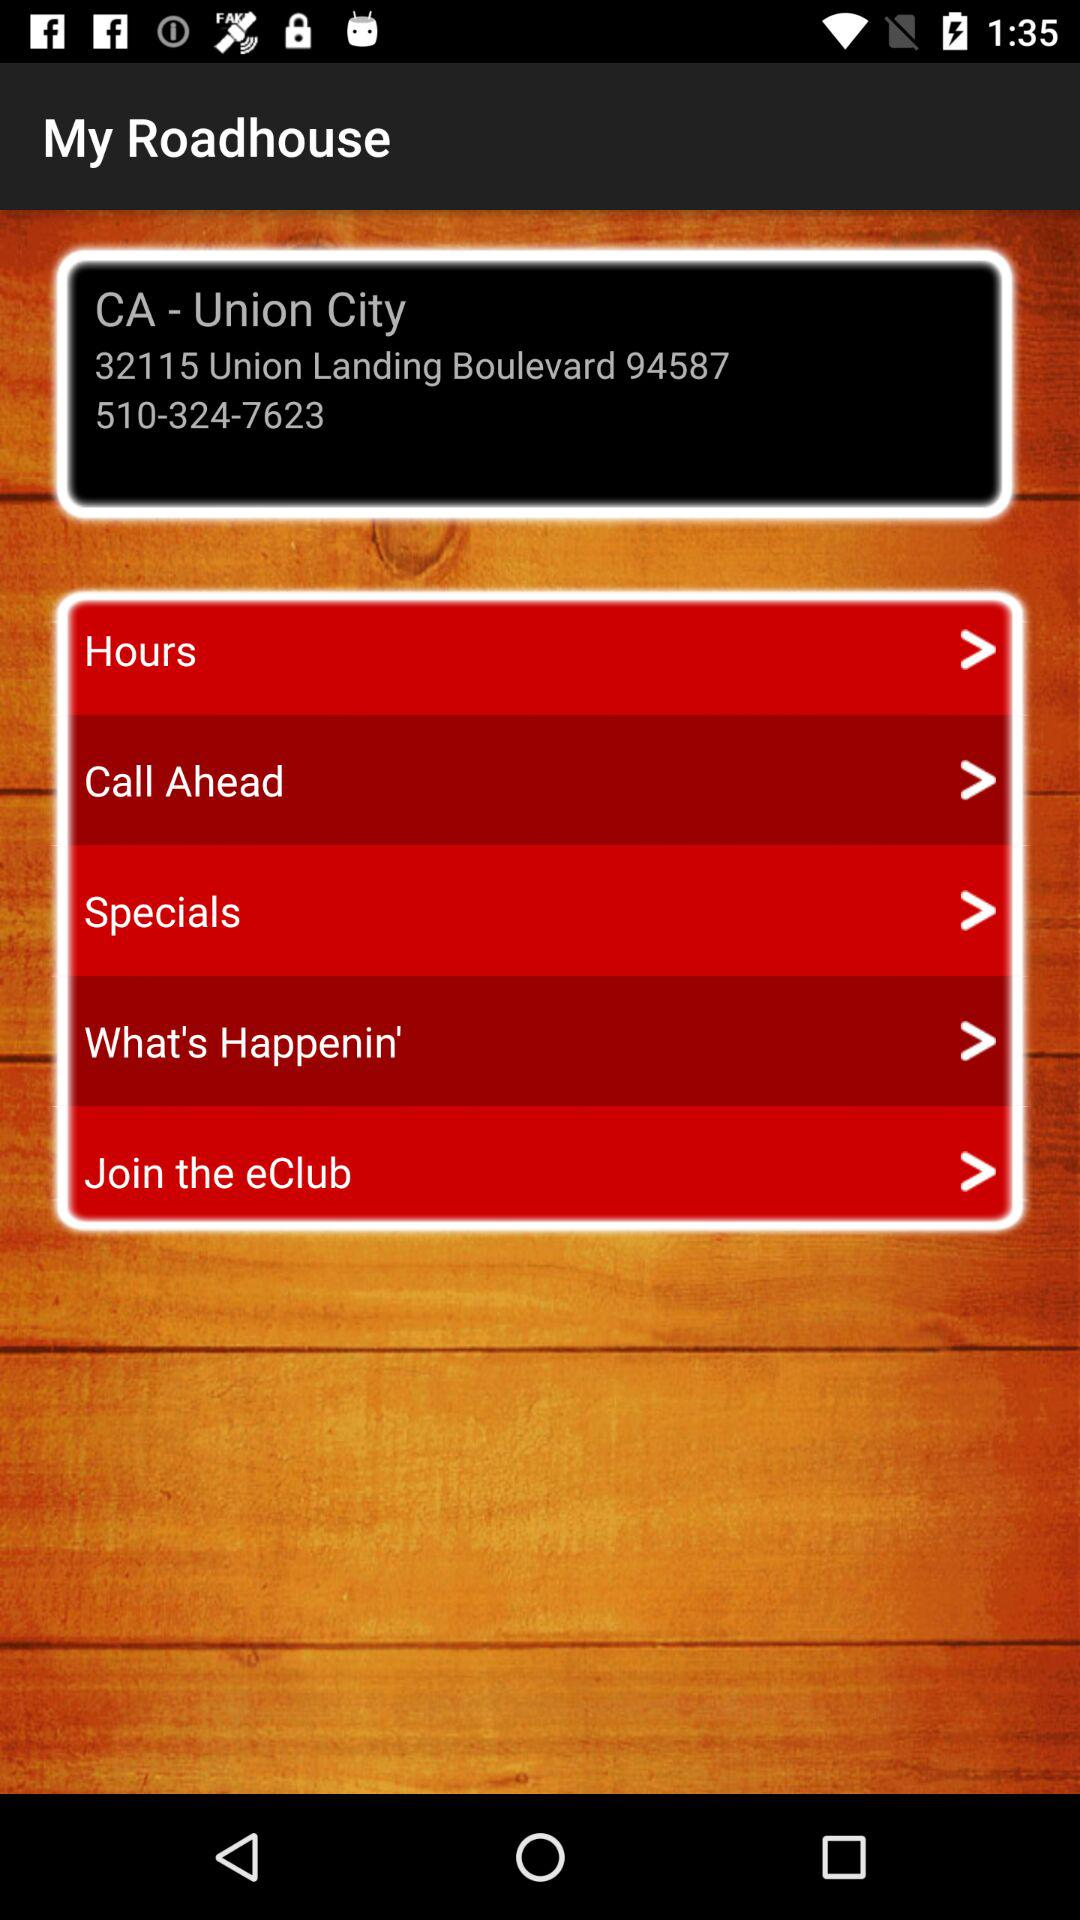What is the contact number? The contact number is 510-324-7623. 